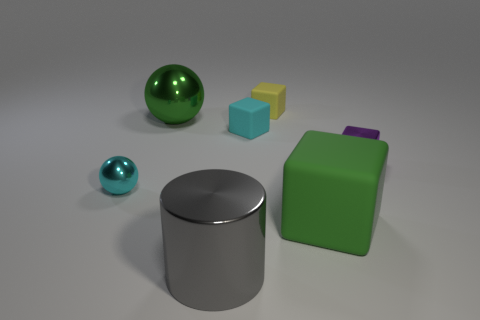What material is the large green thing that is on the left side of the shiny thing that is in front of the tiny object that is to the left of the green shiny thing?
Your answer should be compact. Metal. The green object that is left of the gray metal cylinder on the left side of the big matte block is made of what material?
Provide a short and direct response. Metal. Do the shiny ball right of the cyan sphere and the block that is in front of the tiny metal sphere have the same size?
Make the answer very short. Yes. What number of small things are either cylinders or gray blocks?
Give a very brief answer. 0. What number of things are objects on the right side of the yellow thing or gray things?
Your response must be concise. 3. Does the small shiny ball have the same color as the big cylinder?
Your answer should be very brief. No. What number of other objects are the same shape as the purple object?
Your answer should be very brief. 3. How many brown objects are either cylinders or tiny rubber things?
Keep it short and to the point. 0. What is the color of the big ball that is the same material as the purple cube?
Your answer should be very brief. Green. Does the green object that is behind the cyan shiny thing have the same material as the big thing in front of the big green rubber block?
Provide a succinct answer. Yes. 